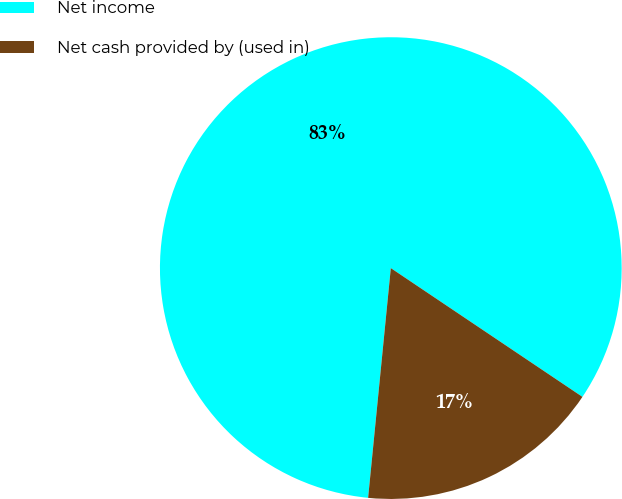Convert chart. <chart><loc_0><loc_0><loc_500><loc_500><pie_chart><fcel>Net income<fcel>Net cash provided by (used in)<nl><fcel>82.85%<fcel>17.15%<nl></chart> 